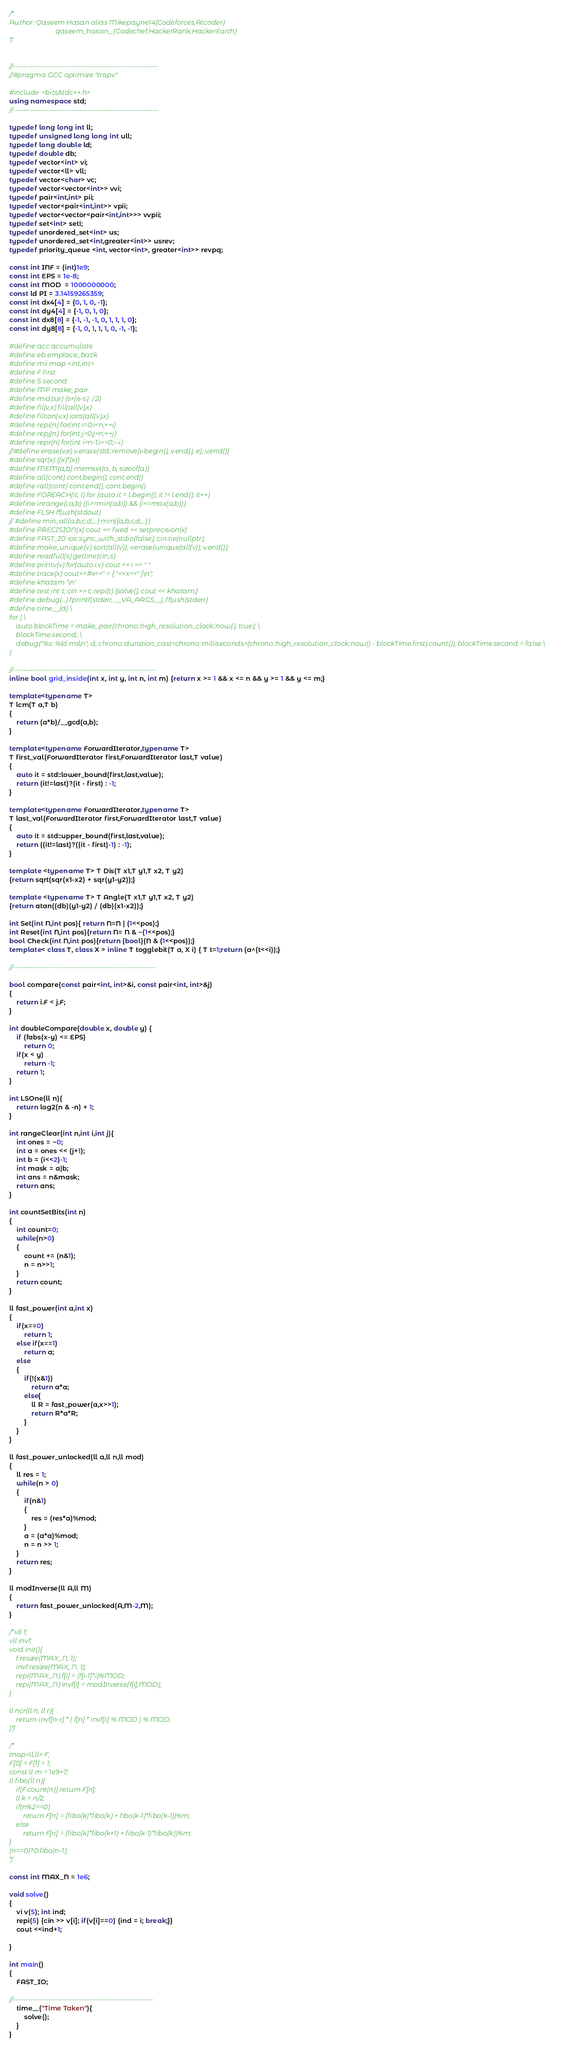Convert code to text. <code><loc_0><loc_0><loc_500><loc_500><_C++_>/*
Author: Qaseem Hasan alias Mikepayne14(Codeforces,Atcoder) 
                           qaseem_hasan_ (Codechef,HackerRank,HackerEarth)
*/


//---------------------------------------------------------
//#pragma GCC optimize "trapv"

#include <bits/stdc++.h>
using namespace std;
//---------------------------------------------------------

typedef long long int ll;
typedef unsigned long long int ull;
typedef long double ld;
typedef double db;
typedef vector<int> vi;
typedef vector<ll> vll;
typedef vector<char> vc;
typedef vector<vector<int>> vvi;
typedef pair<int,int> pii;
typedef vector<pair<int,int>> vpii;
typedef vector<vector<pair<int,int>>> vvpii;
typedef set<int> seti;
typedef unordered_set<int> us;
typedef unordered_set<int,greater<int>> usrev;
typedef priority_queue <int, vector<int>, greater<int>> revpq;

const int INF = (int)1e9;
const int EPS = 1e-8;
const int MOD  = 1000000000;
const ld PI = 3.14159265359;
const int dx4[4] = {0, 1, 0, -1};
const int dy4[4] = {-1, 0, 1, 0};
const int dx8[8] = {-1, -1, -1, 0, 1, 1, 1, 0};
const int dy8[8] = {-1, 0, 1, 1, 1, 0, -1, -1};

#define acc accumulate
#define eb emplace_back
#define mii map <int,int>
#define F first
#define S second
#define MP make_pair
#define mid(s,e) (s+(e-s)/2)
#define fil(v,x) fill(all(v),x)
#define filcon(v,x) iota(all(v),x)
#define repi(n) for(int i=0;i<n;++i)
#define repj(n) for(int j=0;j<n;++j)
#define repr(n) for(int i=n-1;i>=0;--i)
//#define erase(v,e) v.erase(std::remove(v.begin(), v.end(), e), v.end())
#define sqr(x) ((x)*(x))
#define MEM(a,b) memset(a, b, sizeof(a))
#define all(cont) cont.begin(), cont.end()
#define rall(cont) cont.end(), cont.begin()
#define FOREACH(it, l) for (auto it = l.begin(); it != l.end(); it++)
#define inrange(i,a,b) ((i>=min(a,b)) && (i<=max(a,b)))
#define FLSH fflush(stdout)
// #define min_all(a,b,c,d,...) min({a,b,c,d,...})
#define PRECISION(x) cout << fixed << setprecision(x)
#define FAST_IO ios::sync_with_stdio(false); cin.tie(nullptr);
#define make_unique(v) sort(all(v)); v.erase(unique(all(v)), v.end());
#define readfull(s) getline(cin,s)
#define printv(v) for(auto i:v) cout << i << " "
#define trace(x) cout<<#x<<" = { "<<x<<" }\n";
#define khatam '\n'
#define test int t; cin >> t; repi(t) {solve(); cout << khatam;}
#define debug(...) fprintf(stderr, __VA_ARGS__), fflush(stderr)
#define time__(d) \
for ( \
    auto blockTime = make_pair(chrono::high_resolution_clock::now(), true); \
    blockTime.second; \
    debug("%s: %ld ms\n", d, chrono::duration_cast<chrono::milliseconds>(chrono::high_resolution_clock::now() - blockTime.first).count()), blockTime.second = false \
)

//--------------------------------------------------------
inline bool grid_inside(int x, int y, int n, int m) {return x >= 1 && x <= n && y >= 1 && y <= m;}

template<typename T>
T lcm(T a,T b)
{
    return (a*b)/__gcd(a,b);
}

template<typename ForwardIterator,typename T>
T first_val(ForwardIterator first,ForwardIterator last,T value)
{
    auto it = std::lower_bound(first,last,value);
    return (it!=last)?(it - first) : -1;
}

template<typename ForwardIterator,typename T>
T last_val(ForwardIterator first,ForwardIterator last,T value)
{
    auto it = std::upper_bound(first,last,value);
    return ((it!=last)?((it - first)-1) : -1);
}

template <typename T> T Dis(T x1,T y1,T x2, T y2)
{return sqrt(sqr(x1-x2) + sqr(y1-y2));}

template <typename T> T Angle(T x1,T y1,T x2, T y2)
{return atan((db)(y1-y2) / (db)(x1-x2));}

int Set(int N,int pos){ return N=N | (1<<pos);}
int Reset(int N,int pos){return N= N & ~(1<<pos);}
bool Check(int N,int pos){return (bool)(N & (1<<pos));}
template< class T, class X > inline T togglebit(T a, X i) { T t=1;return (a^(t<<i));}

//--------------------------------------------------------

bool compare(const pair<int, int>&i, const pair<int, int>&j)
{
    return i.F < j.F;
}

int doubleCompare(double x, double y) {
    if (fabs(x-y) <= EPS)
        return 0;
    if(x < y)
        return -1;
    return 1;
}

int LSOne(ll n){
    return log2(n & -n) + 1;
}

int rangeClear(int n,int i,int j){
    int ones = ~0;
    int a = ones << (j+1);
    int b = (i<<2)-1;
    int mask = a|b;
    int ans = n&mask;
    return ans;
}

int countSetBits(int n)
{
    int count=0;
    while(n>0)
    {
        count += (n&1);
        n = n>>1;
    }
    return count;
}

ll fast_power(int a,int x)
{
    if(x==0)
        return 1;
    else if(x==1)
        return a;
    else
    {
        if(!(x&1))
            return a*a;
        else{
            ll R = fast_power(a,x>>1);
            return R*a*R;
        }
    }
}

ll fast_power_unlocked(ll a,ll n,ll mod)
{
    ll res = 1;
    while(n > 0)
    {
        if(n&1)
        {
            res = (res*a)%mod;
        }
        a = (a*a)%mod;
        n = n >> 1;
    }
    return res;
}

ll modInverse(ll A,ll M)
{
    return fast_power_unlocked(A,M-2,M);
}

/*vll f;
vll invf;
void init(){
    f.resize(MAX_N, 1);
    invf.resize(MAX_N, 1);
    repi(MAX_N) f[i] = (f[i-1]*i)%MOD;
    repi(MAX_N) invf[i] = modInverse(f[i],MOD);
}

ll ncr(ll n, ll r){
    return invf[n-r] * ( f[n] * invf[r] % MOD ) % MOD;
}*/

/*
map<ll,ll> F;
F[0] = F[1] = 1;
const ll m = 1e9+7;
ll fibo(ll n){
    if(F.count(n)) return F[n];
    ll k = n/2;
    if(n%2==0)
        return F[n] = (fibo(k)*fibo(k) + fibo(k-1)*fibo(k-1))%m;
    else
        return F[n] = (fibo(k)*fibo(k+1) + fibo(k-1)*fibo(k))%m;
}
(n==0)?0:fibo(n-1);
*/

const int MAX_N = 1e6;

void solve()
{
    vi v(5); int ind;
    repi(5) {cin >> v[i]; if(v[i]==0) {ind = i; break;}}
    cout <<ind+1;

}

int main()
{
    FAST_IO;

//-------------------------------------------------------
    time__("Time Taken"){
        solve();
    }
}
</code> 